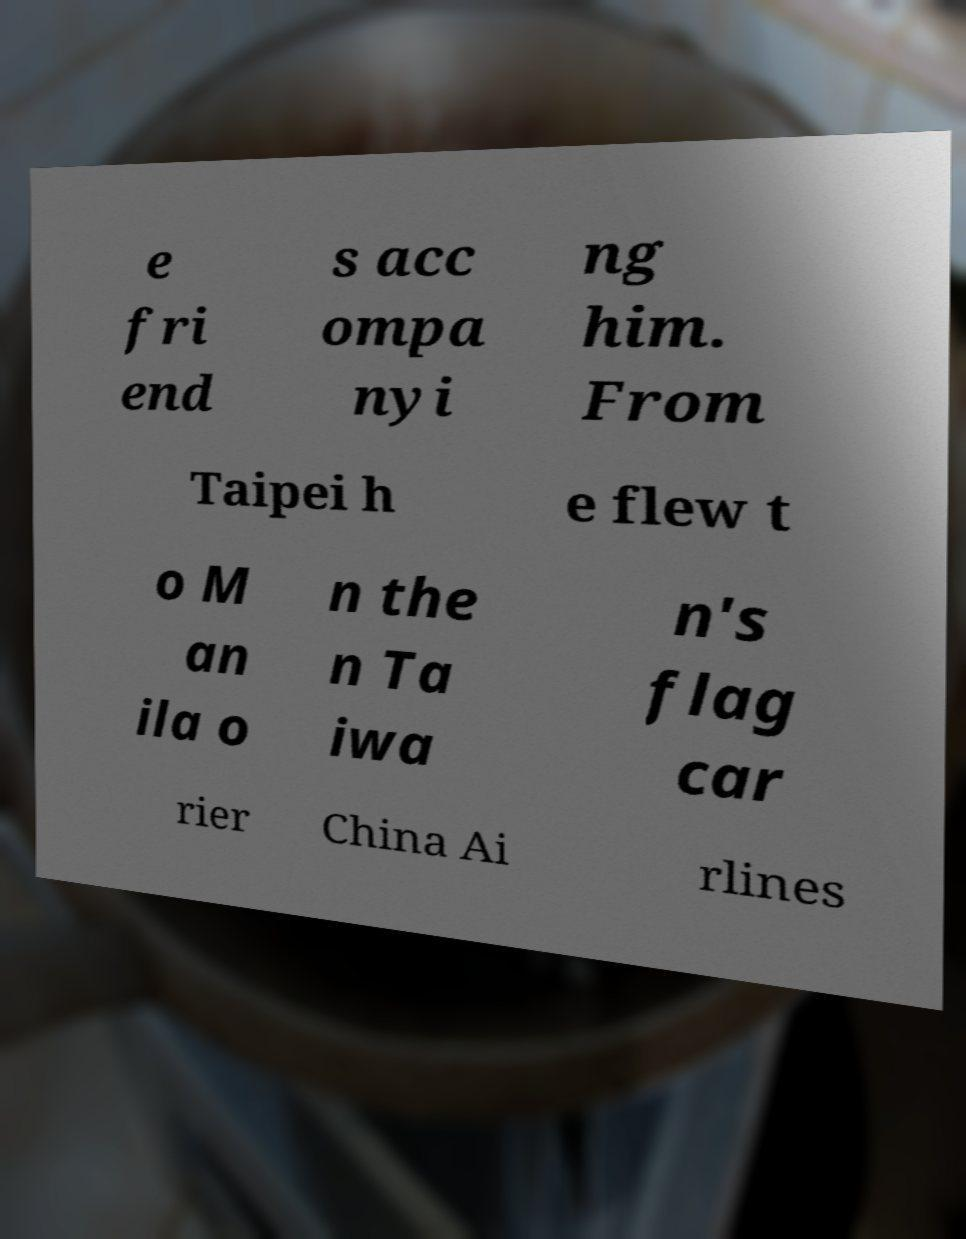I need the written content from this picture converted into text. Can you do that? e fri end s acc ompa nyi ng him. From Taipei h e flew t o M an ila o n the n Ta iwa n's flag car rier China Ai rlines 